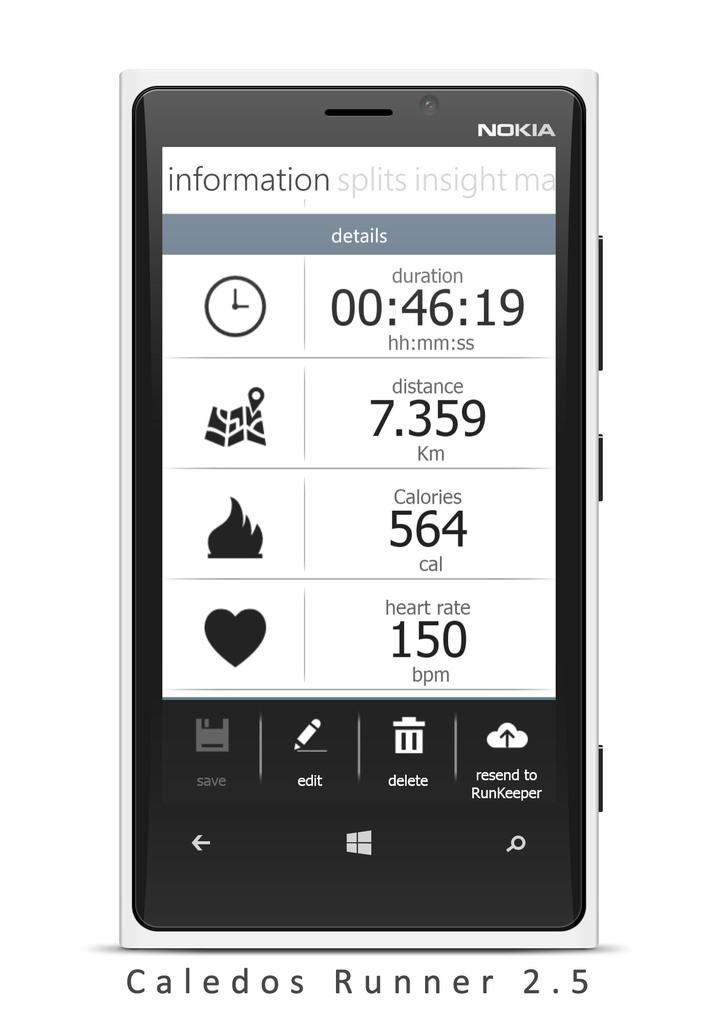Provide a one-sentence caption for the provided image. A collection of fitness stats are displayed on a Nokia phone screen. 